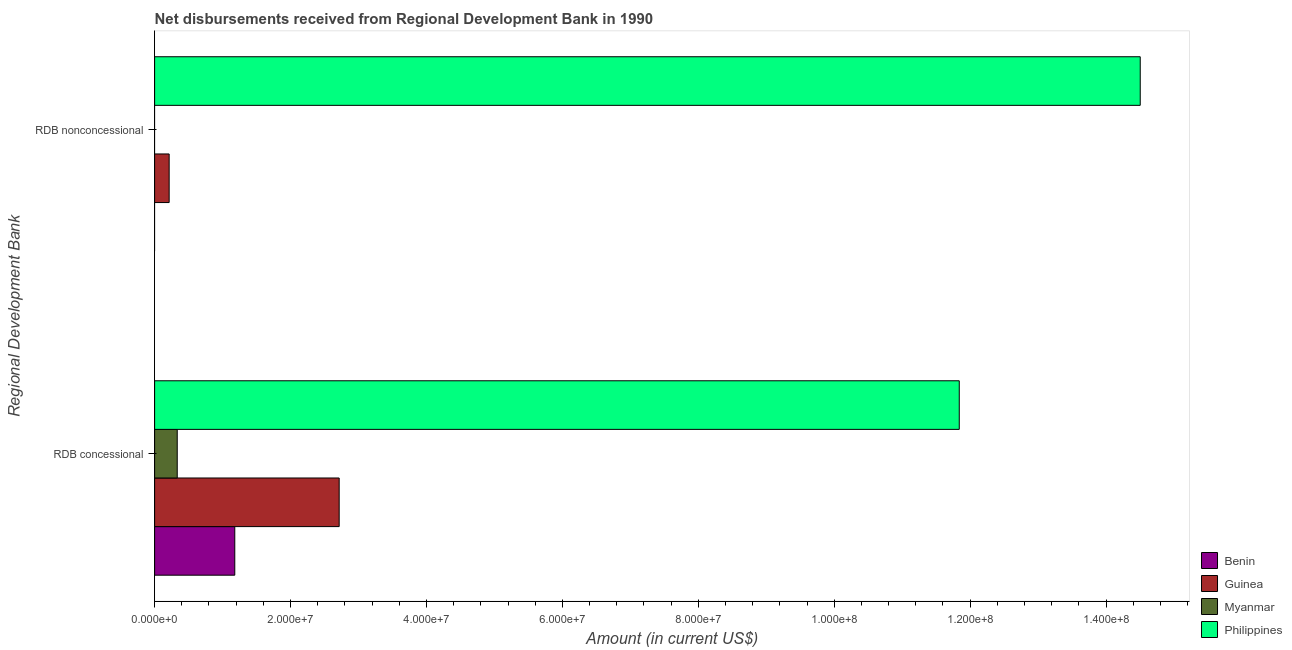How many groups of bars are there?
Your answer should be compact. 2. Are the number of bars per tick equal to the number of legend labels?
Give a very brief answer. No. How many bars are there on the 1st tick from the top?
Keep it short and to the point. 2. How many bars are there on the 1st tick from the bottom?
Provide a short and direct response. 4. What is the label of the 2nd group of bars from the top?
Your answer should be very brief. RDB concessional. What is the net concessional disbursements from rdb in Benin?
Make the answer very short. 1.18e+07. Across all countries, what is the maximum net non concessional disbursements from rdb?
Your answer should be very brief. 1.45e+08. What is the total net non concessional disbursements from rdb in the graph?
Provide a succinct answer. 1.47e+08. What is the difference between the net concessional disbursements from rdb in Philippines and that in Myanmar?
Keep it short and to the point. 1.15e+08. What is the difference between the net concessional disbursements from rdb in Philippines and the net non concessional disbursements from rdb in Myanmar?
Provide a short and direct response. 1.18e+08. What is the average net non concessional disbursements from rdb per country?
Ensure brevity in your answer.  3.68e+07. What is the difference between the net non concessional disbursements from rdb and net concessional disbursements from rdb in Philippines?
Make the answer very short. 2.66e+07. What is the ratio of the net concessional disbursements from rdb in Guinea to that in Benin?
Offer a terse response. 2.3. Is the net concessional disbursements from rdb in Myanmar less than that in Philippines?
Ensure brevity in your answer.  Yes. How many bars are there?
Your response must be concise. 6. What is the difference between two consecutive major ticks on the X-axis?
Keep it short and to the point. 2.00e+07. Are the values on the major ticks of X-axis written in scientific E-notation?
Give a very brief answer. Yes. What is the title of the graph?
Offer a very short reply. Net disbursements received from Regional Development Bank in 1990. What is the label or title of the Y-axis?
Offer a very short reply. Regional Development Bank. What is the Amount (in current US$) in Benin in RDB concessional?
Keep it short and to the point. 1.18e+07. What is the Amount (in current US$) of Guinea in RDB concessional?
Your answer should be very brief. 2.72e+07. What is the Amount (in current US$) in Myanmar in RDB concessional?
Your response must be concise. 3.33e+06. What is the Amount (in current US$) in Philippines in RDB concessional?
Give a very brief answer. 1.18e+08. What is the Amount (in current US$) of Benin in RDB nonconcessional?
Make the answer very short. 0. What is the Amount (in current US$) in Guinea in RDB nonconcessional?
Your answer should be very brief. 2.14e+06. What is the Amount (in current US$) in Philippines in RDB nonconcessional?
Give a very brief answer. 1.45e+08. Across all Regional Development Bank, what is the maximum Amount (in current US$) of Benin?
Your response must be concise. 1.18e+07. Across all Regional Development Bank, what is the maximum Amount (in current US$) in Guinea?
Give a very brief answer. 2.72e+07. Across all Regional Development Bank, what is the maximum Amount (in current US$) of Myanmar?
Keep it short and to the point. 3.33e+06. Across all Regional Development Bank, what is the maximum Amount (in current US$) in Philippines?
Make the answer very short. 1.45e+08. Across all Regional Development Bank, what is the minimum Amount (in current US$) of Guinea?
Provide a short and direct response. 2.14e+06. Across all Regional Development Bank, what is the minimum Amount (in current US$) in Myanmar?
Provide a short and direct response. 0. Across all Regional Development Bank, what is the minimum Amount (in current US$) of Philippines?
Your answer should be compact. 1.18e+08. What is the total Amount (in current US$) of Benin in the graph?
Your answer should be very brief. 1.18e+07. What is the total Amount (in current US$) of Guinea in the graph?
Your answer should be compact. 2.93e+07. What is the total Amount (in current US$) of Myanmar in the graph?
Ensure brevity in your answer.  3.33e+06. What is the total Amount (in current US$) of Philippines in the graph?
Give a very brief answer. 2.63e+08. What is the difference between the Amount (in current US$) in Guinea in RDB concessional and that in RDB nonconcessional?
Provide a short and direct response. 2.50e+07. What is the difference between the Amount (in current US$) in Philippines in RDB concessional and that in RDB nonconcessional?
Your response must be concise. -2.66e+07. What is the difference between the Amount (in current US$) in Benin in RDB concessional and the Amount (in current US$) in Guinea in RDB nonconcessional?
Ensure brevity in your answer.  9.66e+06. What is the difference between the Amount (in current US$) of Benin in RDB concessional and the Amount (in current US$) of Philippines in RDB nonconcessional?
Keep it short and to the point. -1.33e+08. What is the difference between the Amount (in current US$) in Guinea in RDB concessional and the Amount (in current US$) in Philippines in RDB nonconcessional?
Provide a succinct answer. -1.18e+08. What is the difference between the Amount (in current US$) in Myanmar in RDB concessional and the Amount (in current US$) in Philippines in RDB nonconcessional?
Keep it short and to the point. -1.42e+08. What is the average Amount (in current US$) in Benin per Regional Development Bank?
Your response must be concise. 5.90e+06. What is the average Amount (in current US$) of Guinea per Regional Development Bank?
Ensure brevity in your answer.  1.46e+07. What is the average Amount (in current US$) in Myanmar per Regional Development Bank?
Give a very brief answer. 1.66e+06. What is the average Amount (in current US$) of Philippines per Regional Development Bank?
Offer a terse response. 1.32e+08. What is the difference between the Amount (in current US$) in Benin and Amount (in current US$) in Guinea in RDB concessional?
Provide a succinct answer. -1.54e+07. What is the difference between the Amount (in current US$) of Benin and Amount (in current US$) of Myanmar in RDB concessional?
Provide a short and direct response. 8.47e+06. What is the difference between the Amount (in current US$) of Benin and Amount (in current US$) of Philippines in RDB concessional?
Provide a short and direct response. -1.07e+08. What is the difference between the Amount (in current US$) of Guinea and Amount (in current US$) of Myanmar in RDB concessional?
Ensure brevity in your answer.  2.38e+07. What is the difference between the Amount (in current US$) of Guinea and Amount (in current US$) of Philippines in RDB concessional?
Ensure brevity in your answer.  -9.12e+07. What is the difference between the Amount (in current US$) of Myanmar and Amount (in current US$) of Philippines in RDB concessional?
Your answer should be compact. -1.15e+08. What is the difference between the Amount (in current US$) of Guinea and Amount (in current US$) of Philippines in RDB nonconcessional?
Provide a short and direct response. -1.43e+08. What is the ratio of the Amount (in current US$) of Guinea in RDB concessional to that in RDB nonconcessional?
Offer a very short reply. 12.69. What is the ratio of the Amount (in current US$) of Philippines in RDB concessional to that in RDB nonconcessional?
Provide a short and direct response. 0.82. What is the difference between the highest and the second highest Amount (in current US$) in Guinea?
Make the answer very short. 2.50e+07. What is the difference between the highest and the second highest Amount (in current US$) in Philippines?
Offer a very short reply. 2.66e+07. What is the difference between the highest and the lowest Amount (in current US$) of Benin?
Give a very brief answer. 1.18e+07. What is the difference between the highest and the lowest Amount (in current US$) in Guinea?
Your answer should be very brief. 2.50e+07. What is the difference between the highest and the lowest Amount (in current US$) of Myanmar?
Provide a succinct answer. 3.33e+06. What is the difference between the highest and the lowest Amount (in current US$) of Philippines?
Give a very brief answer. 2.66e+07. 